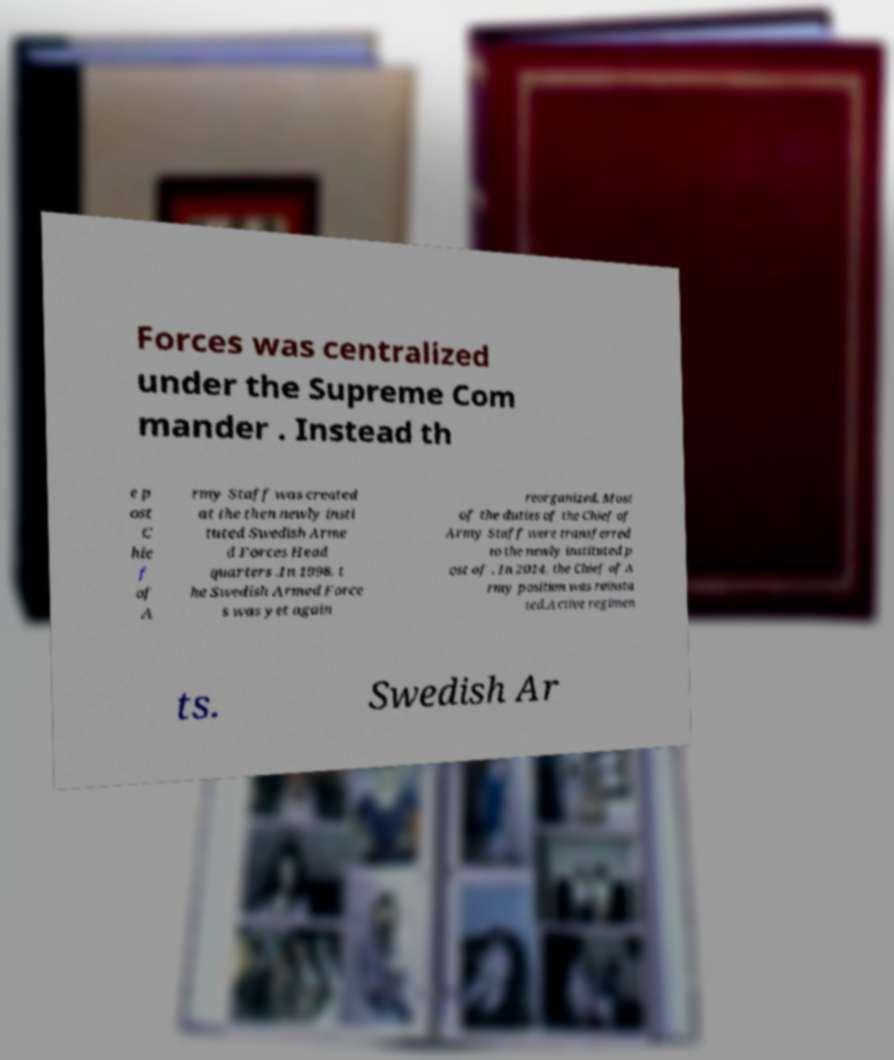I need the written content from this picture converted into text. Can you do that? Forces was centralized under the Supreme Com mander . Instead th e p ost C hie f of A rmy Staff was created at the then newly insti tuted Swedish Arme d Forces Head quarters .In 1998, t he Swedish Armed Force s was yet again reorganized. Most of the duties of the Chief of Army Staff were transferred to the newly instituted p ost of . In 2014, the Chief of A rmy position was reinsta ted.Active regimen ts. Swedish Ar 